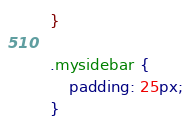<code> <loc_0><loc_0><loc_500><loc_500><_CSS_>}

.mysidebar {
    padding: 25px;
}
</code> 